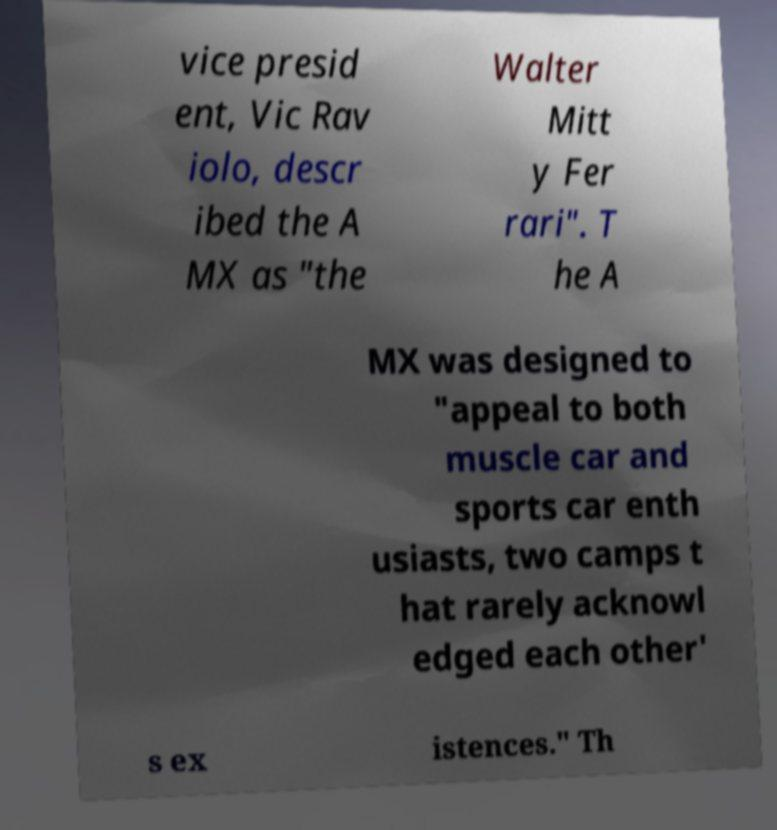Could you assist in decoding the text presented in this image and type it out clearly? vice presid ent, Vic Rav iolo, descr ibed the A MX as "the Walter Mitt y Fer rari". T he A MX was designed to "appeal to both muscle car and sports car enth usiasts, two camps t hat rarely acknowl edged each other' s ex istences." Th 